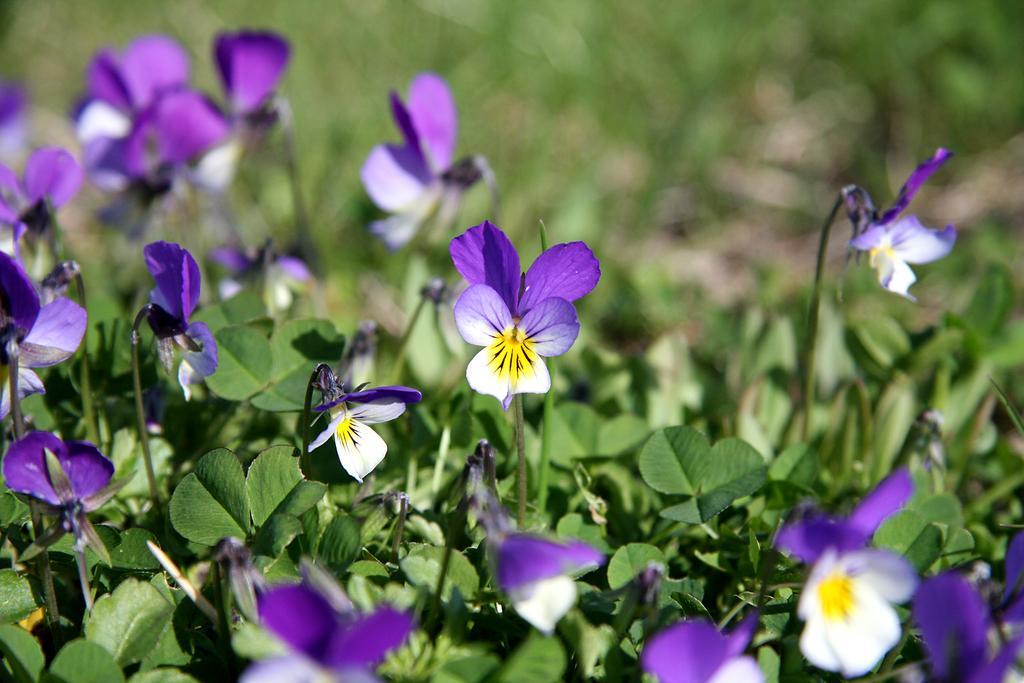In one or two sentences, can you explain what this image depicts? There are flower plants in the image and the background area is blur. 